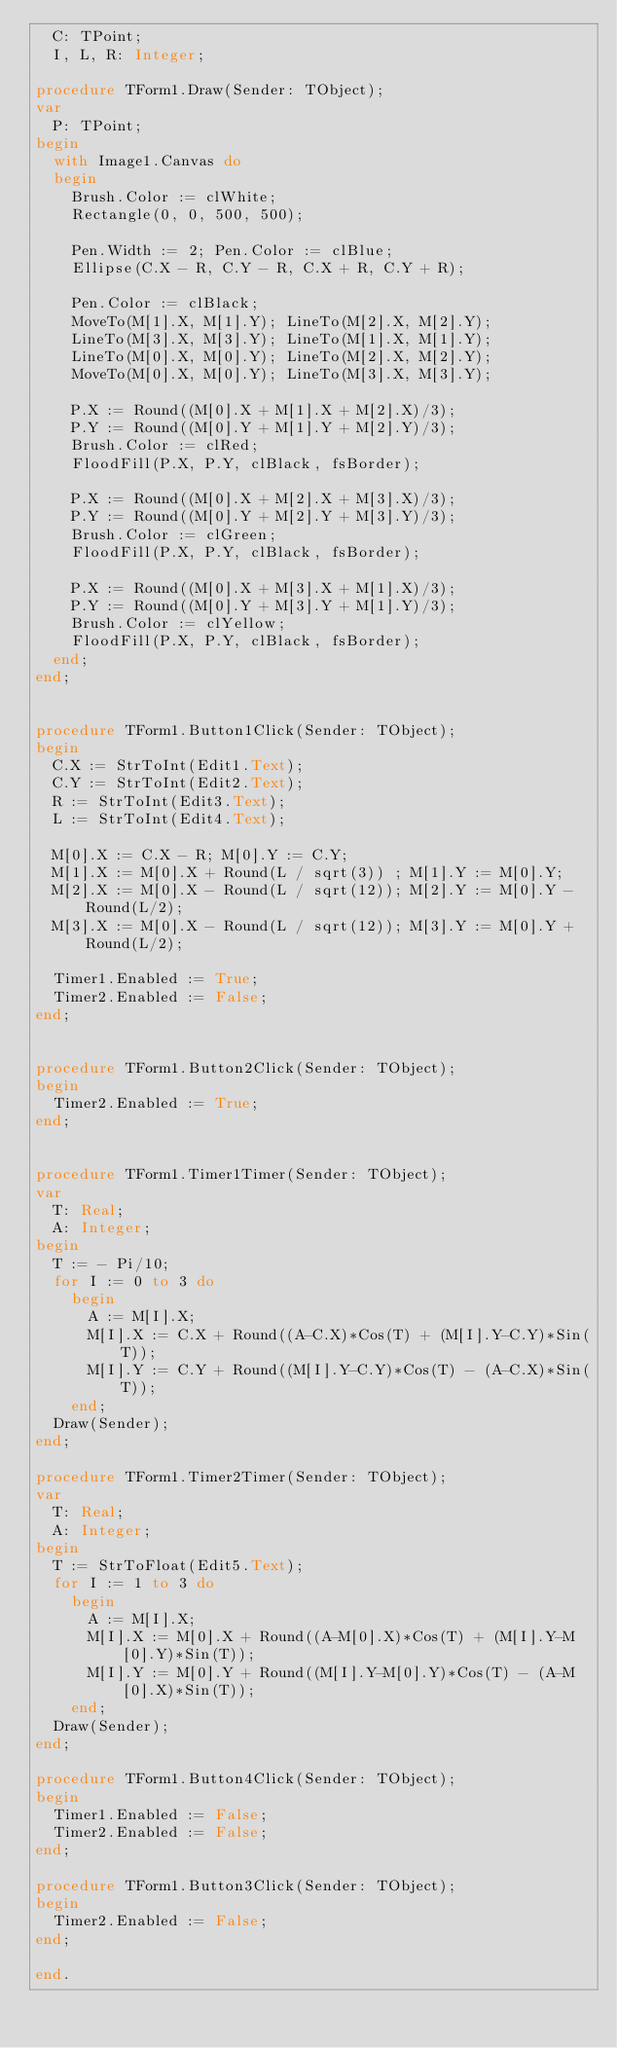Convert code to text. <code><loc_0><loc_0><loc_500><loc_500><_Pascal_>  C: TPoint;
  I, L, R: Integer;

procedure TForm1.Draw(Sender: TObject);
var
  P: TPoint;
begin
  with Image1.Canvas do
  begin
    Brush.Color := clWhite;
    Rectangle(0, 0, 500, 500);
    
    Pen.Width := 2; Pen.Color := clBlue;
    Ellipse(C.X - R, C.Y - R, C.X + R, C.Y + R);

    Pen.Color := clBlack;
    MoveTo(M[1].X, M[1].Y); LineTo(M[2].X, M[2].Y);
    LineTo(M[3].X, M[3].Y); LineTo(M[1].X, M[1].Y);
    LineTo(M[0].X, M[0].Y); LineTo(M[2].X, M[2].Y);
    MoveTo(M[0].X, M[0].Y); LineTo(M[3].X, M[3].Y);

    P.X := Round((M[0].X + M[1].X + M[2].X)/3);
    P.Y := Round((M[0].Y + M[1].Y + M[2].Y)/3);
    Brush.Color := clRed;
    FloodFill(P.X, P.Y, clBlack, fsBorder);

    P.X := Round((M[0].X + M[2].X + M[3].X)/3);
    P.Y := Round((M[0].Y + M[2].Y + M[3].Y)/3);
    Brush.Color := clGreen;
    FloodFill(P.X, P.Y, clBlack, fsBorder);

    P.X := Round((M[0].X + M[3].X + M[1].X)/3);
    P.Y := Round((M[0].Y + M[3].Y + M[1].Y)/3);
    Brush.Color := clYellow;
    FloodFill(P.X, P.Y, clBlack, fsBorder);
  end;
end;


procedure TForm1.Button1Click(Sender: TObject);
begin
  C.X := StrToInt(Edit1.Text);
  C.Y := StrToInt(Edit2.Text);
  R := StrToInt(Edit3.Text);
  L := StrToInt(Edit4.Text);

  M[0].X := C.X - R; M[0].Y := C.Y;
  M[1].X := M[0].X + Round(L / sqrt(3)) ; M[1].Y := M[0].Y;
  M[2].X := M[0].X - Round(L / sqrt(12)); M[2].Y := M[0].Y - Round(L/2);
  M[3].X := M[0].X - Round(L / sqrt(12)); M[3].Y := M[0].Y + Round(L/2);

  Timer1.Enabled := True;
  Timer2.Enabled := False;
end;


procedure TForm1.Button2Click(Sender: TObject);
begin
  Timer2.Enabled := True;
end;


procedure TForm1.Timer1Timer(Sender: TObject);
var
  T: Real;
  A: Integer;
begin
  T := - Pi/10;
  for I := 0 to 3 do
    begin
      A := M[I].X;
      M[I].X := C.X + Round((A-C.X)*Cos(T) + (M[I].Y-C.Y)*Sin(T));
      M[I].Y := C.Y + Round((M[I].Y-C.Y)*Cos(T) - (A-C.X)*Sin(T));
    end;
  Draw(Sender);
end;

procedure TForm1.Timer2Timer(Sender: TObject);
var
  T: Real;
  A: Integer;
begin
  T := StrToFloat(Edit5.Text);
  for I := 1 to 3 do
    begin
      A := M[I].X;
      M[I].X := M[0].X + Round((A-M[0].X)*Cos(T) + (M[I].Y-M[0].Y)*Sin(T));
      M[I].Y := M[0].Y + Round((M[I].Y-M[0].Y)*Cos(T) - (A-M[0].X)*Sin(T));
    end;
  Draw(Sender);
end;

procedure TForm1.Button4Click(Sender: TObject);
begin
  Timer1.Enabled := False;
  Timer2.Enabled := False;
end;

procedure TForm1.Button3Click(Sender: TObject);
begin
  Timer2.Enabled := False;
end;

end.
</code> 